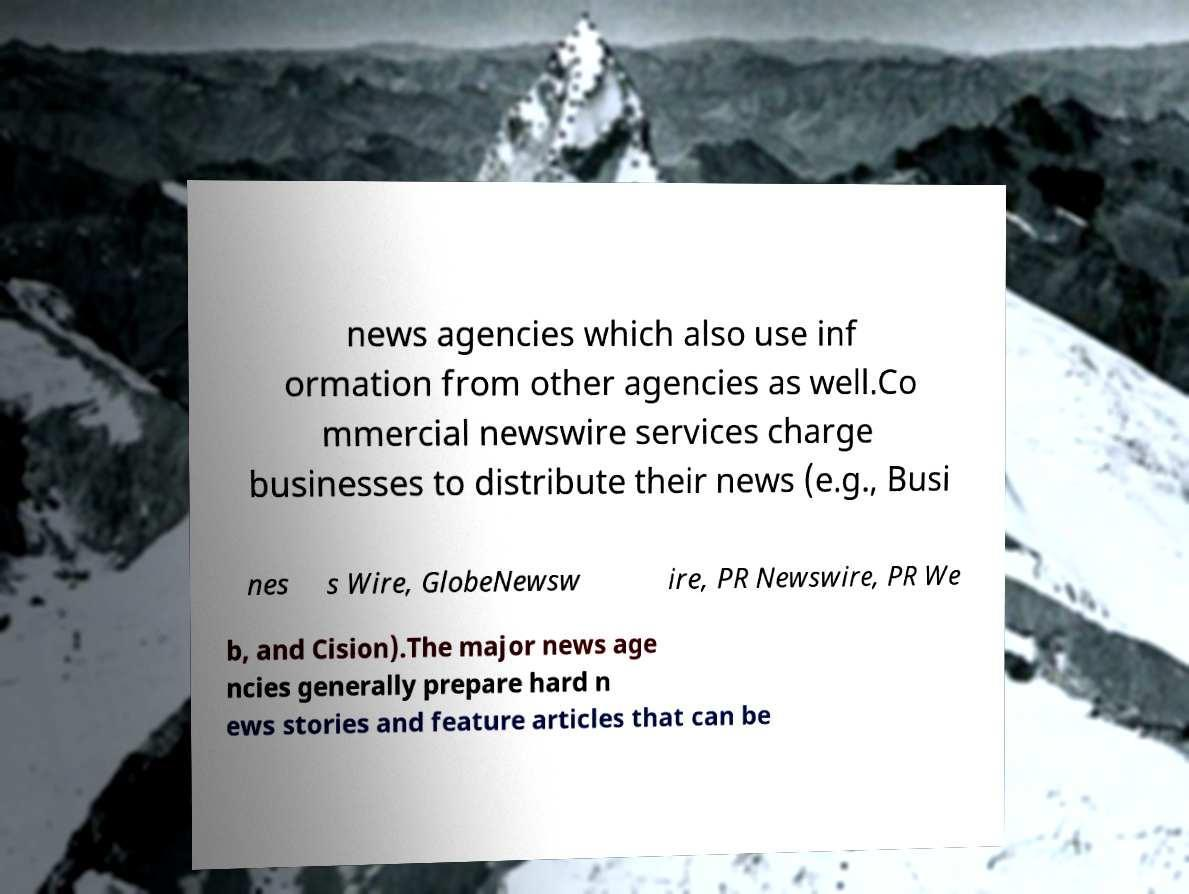Can you read and provide the text displayed in the image?This photo seems to have some interesting text. Can you extract and type it out for me? news agencies which also use inf ormation from other agencies as well.Co mmercial newswire services charge businesses to distribute their news (e.g., Busi nes s Wire, GlobeNewsw ire, PR Newswire, PR We b, and Cision).The major news age ncies generally prepare hard n ews stories and feature articles that can be 